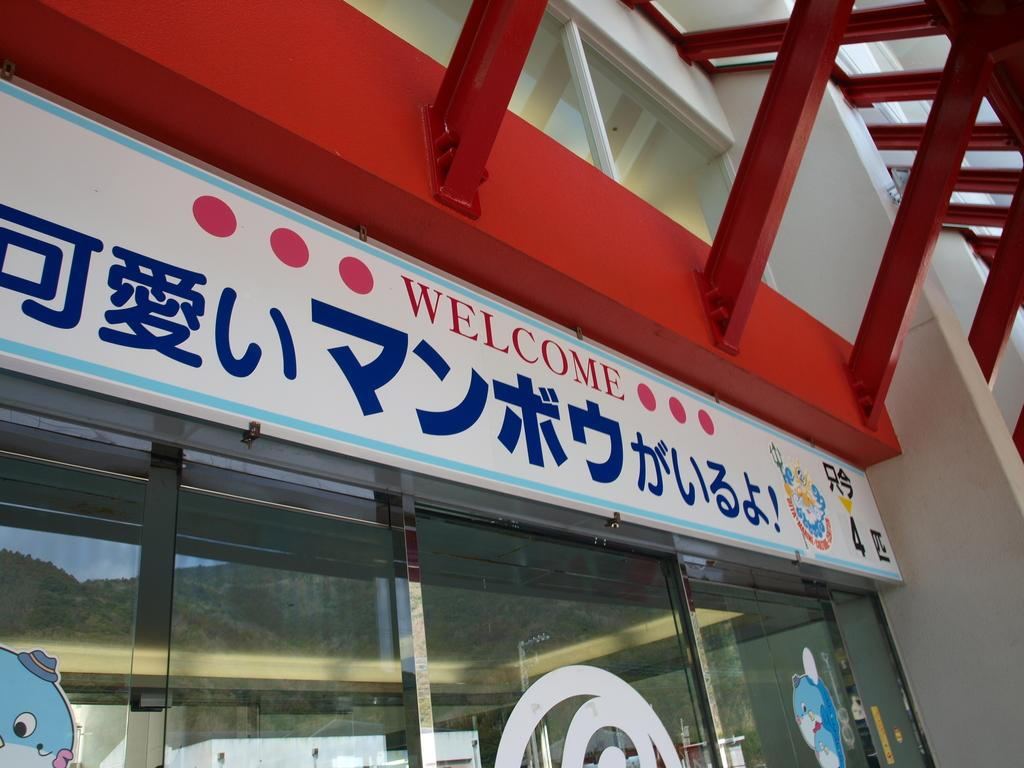What type of structure is visible in the image? There is a building in the image. What is attached to the building? There is a board on the building. What color are the grills in the image? The grills in the image are red. What material is used for the walls of the building? The building has glass walls. What is displayed on the glass walls? There are posters pasted on the glass walls. Can you see a volleyball game being played in the image? There is no volleyball game visible in the image. What type of sock is hanging from the board on the building? There is no sock present in the image. 